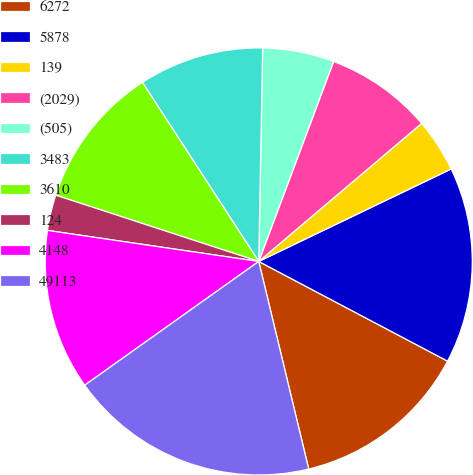Convert chart. <chart><loc_0><loc_0><loc_500><loc_500><pie_chart><fcel>6272<fcel>5878<fcel>139<fcel>(2029)<fcel>(505)<fcel>3483<fcel>3610<fcel>124<fcel>4148<fcel>49113<nl><fcel>13.51%<fcel>14.86%<fcel>4.06%<fcel>8.11%<fcel>5.41%<fcel>9.46%<fcel>10.81%<fcel>2.7%<fcel>12.16%<fcel>18.92%<nl></chart> 